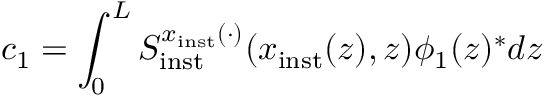Convert formula to latex. <formula><loc_0><loc_0><loc_500><loc_500>c _ { 1 } = \int _ { 0 } ^ { L } S _ { i n s t } ^ { x _ { i n s t } ( \cdot ) } ( x _ { i n s t } ( z ) , z ) \phi _ { 1 } ( z ) ^ { \ast } d z</formula> 